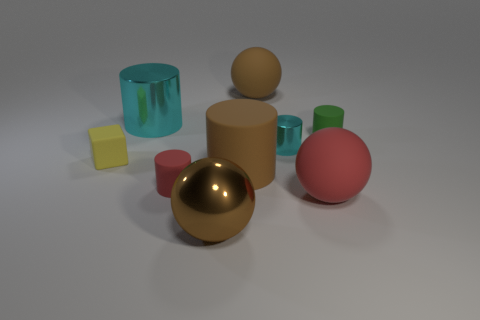The big cylinder that is behind the small rubber thing behind the small yellow rubber thing is made of what material?
Keep it short and to the point. Metal. There is a metal object that is the same color as the small metallic cylinder; what is its shape?
Provide a succinct answer. Cylinder. Are there any brown objects that have the same material as the small red cylinder?
Offer a terse response. Yes. The small green rubber thing has what shape?
Provide a succinct answer. Cylinder. How many tiny cyan matte objects are there?
Offer a very short reply. 0. There is a rubber cylinder in front of the large brown cylinder that is in front of the small metallic thing; what is its color?
Provide a short and direct response. Red. What color is the matte cylinder that is the same size as the red sphere?
Give a very brief answer. Brown. Are there any other shiny objects that have the same color as the tiny metal object?
Ensure brevity in your answer.  Yes. Are any gray cylinders visible?
Offer a very short reply. No. There is a metallic thing that is in front of the big red rubber thing; what shape is it?
Offer a very short reply. Sphere. 